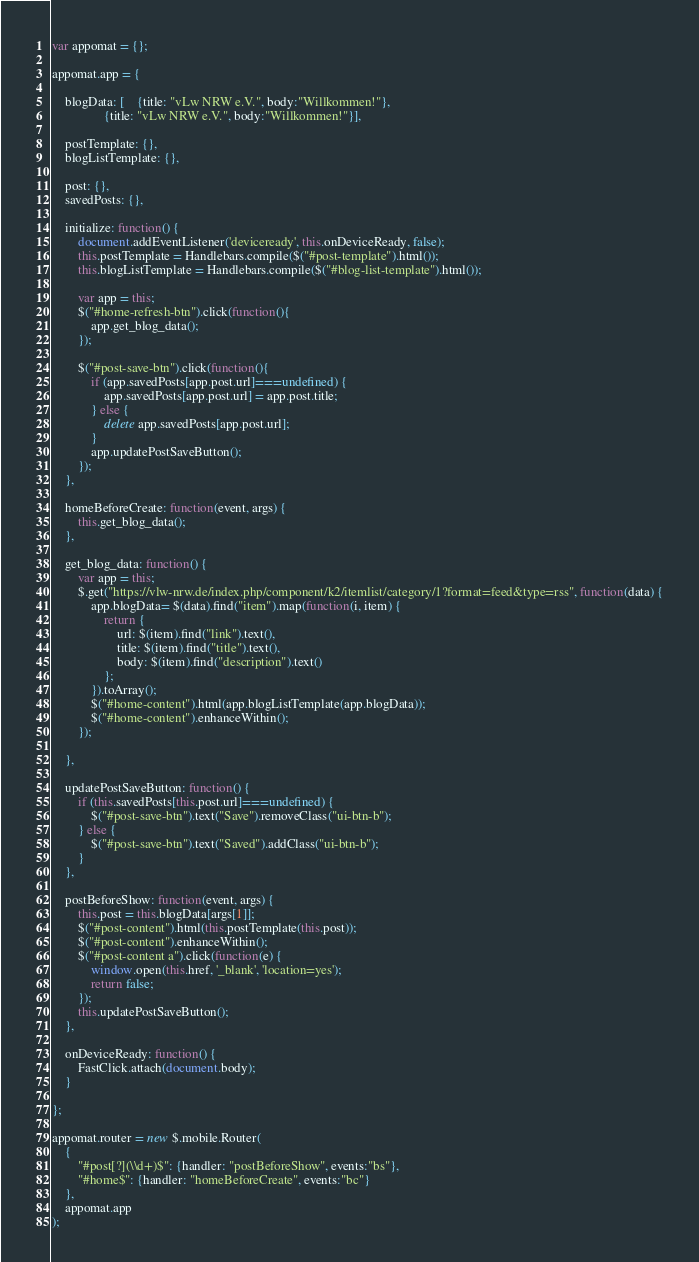Convert code to text. <code><loc_0><loc_0><loc_500><loc_500><_JavaScript_>var appomat = {};

appomat.app = {
	
	blogData: [	{title: "vLw NRW e.V.", body:"Willkommen!"}, 
				{title: "vLw NRW e.V.", body:"Willkommen!"}],
	
	postTemplate: {},	
	blogListTemplate: {},

	post: {},
	savedPosts: {},

	initialize: function() {
		document.addEventListener('deviceready', this.onDeviceReady, false);
		this.postTemplate = Handlebars.compile($("#post-template").html());
		this.blogListTemplate = Handlebars.compile($("#blog-list-template").html());
		
		var app = this;
		$("#home-refresh-btn").click(function(){
			app.get_blog_data();
		});
		
		$("#post-save-btn").click(function(){
			if (app.savedPosts[app.post.url]===undefined) {
				app.savedPosts[app.post.url] = app.post.title;
			} else {
				delete app.savedPosts[app.post.url];
			}
			app.updatePostSaveButton();
		});
    },

	homeBeforeCreate: function(event, args) {
		this.get_blog_data();
	},
	
	get_blog_data: function() {
		var app = this;
		$.get("https://vlw-nrw.de/index.php/component/k2/itemlist/category/1?format=feed&type=rss", function(data) {
			app.blogData= $(data).find("item").map(function(i, item) {
				return { 
					url: $(item).find("link").text(), 
					title: $(item).find("title").text(), 
					body: $(item).find("description").text()
				};
			}).toArray();
			$("#home-content").html(app.blogListTemplate(app.blogData));
			$("#home-content").enhanceWithin();
		});
		
	},
	
	updatePostSaveButton: function() {
		if (this.savedPosts[this.post.url]===undefined) {
			$("#post-save-btn").text("Save").removeClass("ui-btn-b");
		} else {
			$("#post-save-btn").text("Saved").addClass("ui-btn-b");			
		}
 	},

	postBeforeShow: function(event, args) {
		this.post = this.blogData[args[1]];
		$("#post-content").html(this.postTemplate(this.post));
		$("#post-content").enhanceWithin();
		$("#post-content a").click(function(e) {
			window.open(this.href, '_blank', 'location=yes'); 
			return false;	
		});
		this.updatePostSaveButton();
	},

	onDeviceReady: function() {
		FastClick.attach(document.body);		
    }

};

appomat.router = new $.mobile.Router(
	{
		"#post[?](\\d+)$": {handler: "postBeforeShow", events:"bs"},
		"#home$": {handler: "homeBeforeCreate", events:"bc"}
	}, 
	appomat.app
);</code> 